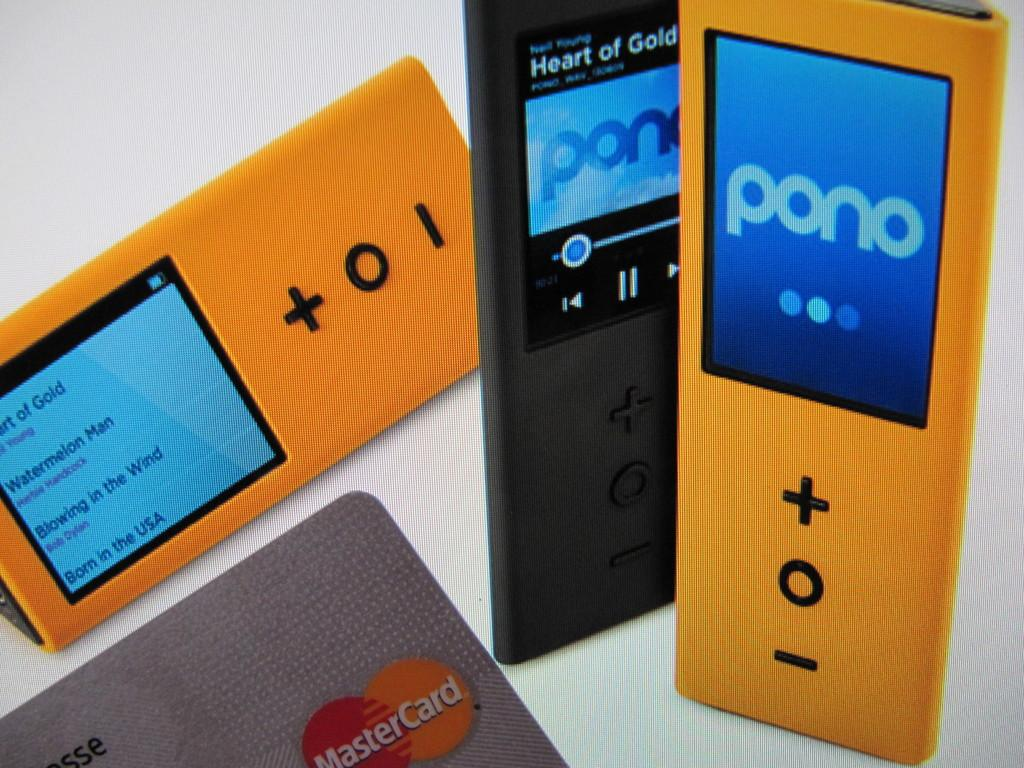What type of electronic device is present in the image? There are three airpods in the image. What colors are the airpods? The airpods are in orange and black color. What is placed in front of the airpods? There is a card in front of the airpods. What color is the background of the image? The background of the image is white. Reasoning: Let' Let's think step by step in order to produce the conversation. We start by identifying the main subject in the image, which is the three airpods. Then, we describe the colors of the airpods to provide more detail. Next, we mention the card that is placed in front of the airpods, which adds context to the image. Finally, we describe the background color to give a sense of the overall visual aesthetic. Absurd Question/Answer: Can you see any fairies flying around the airpods in the image? No, there are no fairies present in the image. How does the cream on the card turn into butter in the image? There is no cream or butter present in the image; it only features airpods and a card. 